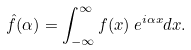Convert formula to latex. <formula><loc_0><loc_0><loc_500><loc_500>\hat { f } ( \alpha ) = \int _ { - \infty } ^ { \infty } f ( x ) \, e ^ { i \alpha x } d x .</formula> 